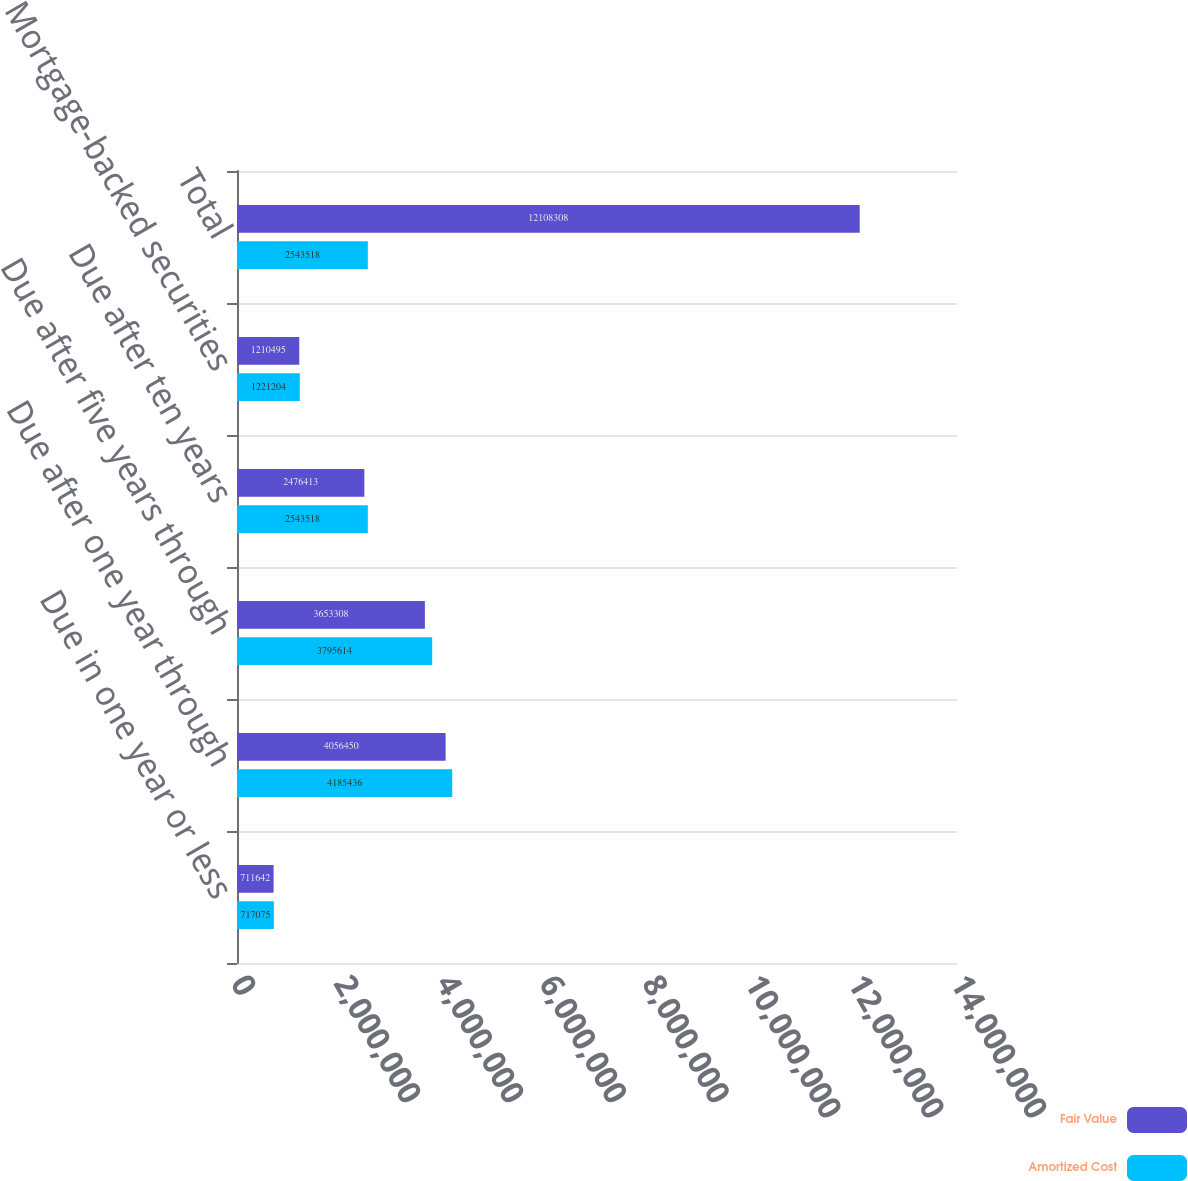<chart> <loc_0><loc_0><loc_500><loc_500><stacked_bar_chart><ecel><fcel>Due in one year or less<fcel>Due after one year through<fcel>Due after five years through<fcel>Due after ten years<fcel>Mortgage-backed securities<fcel>Total<nl><fcel>Fair Value<fcel>711642<fcel>4.05645e+06<fcel>3.65331e+06<fcel>2.47641e+06<fcel>1.2105e+06<fcel>1.21083e+07<nl><fcel>Amortized Cost<fcel>717075<fcel>4.18544e+06<fcel>3.79561e+06<fcel>2.54352e+06<fcel>1.2212e+06<fcel>2.54352e+06<nl></chart> 